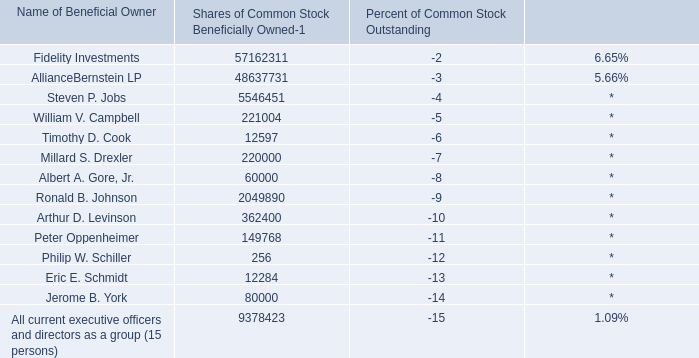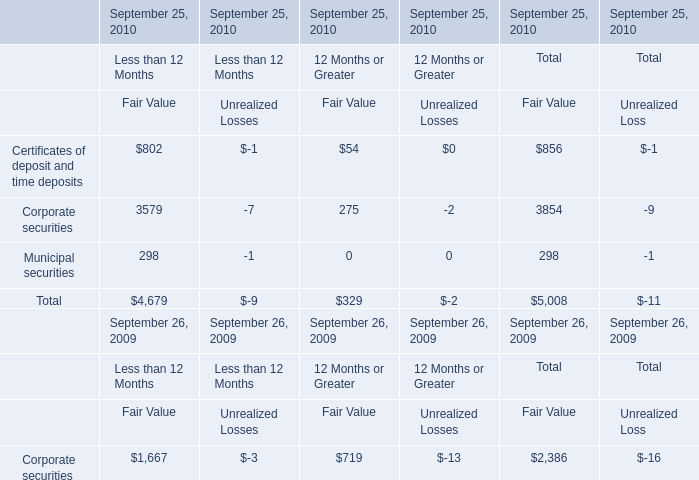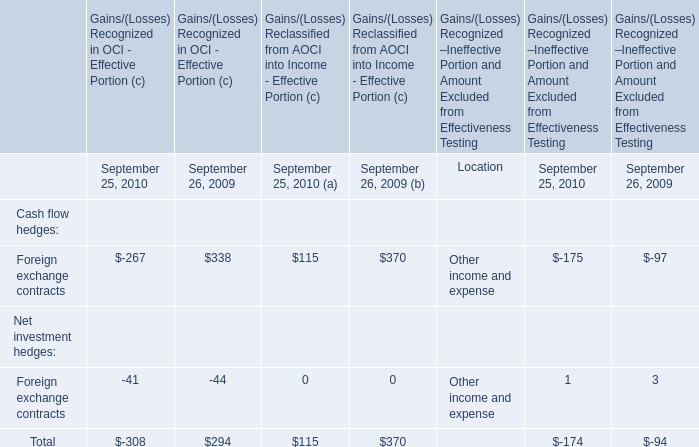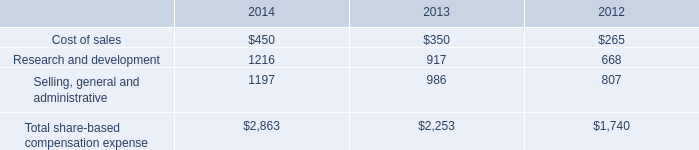What's the average of Certificates of deposit and time deposits and Corporate securities for Fair Value of Total in 2010? 
Computations: ((856 + 3854) / 2)
Answer: 2355.0. 